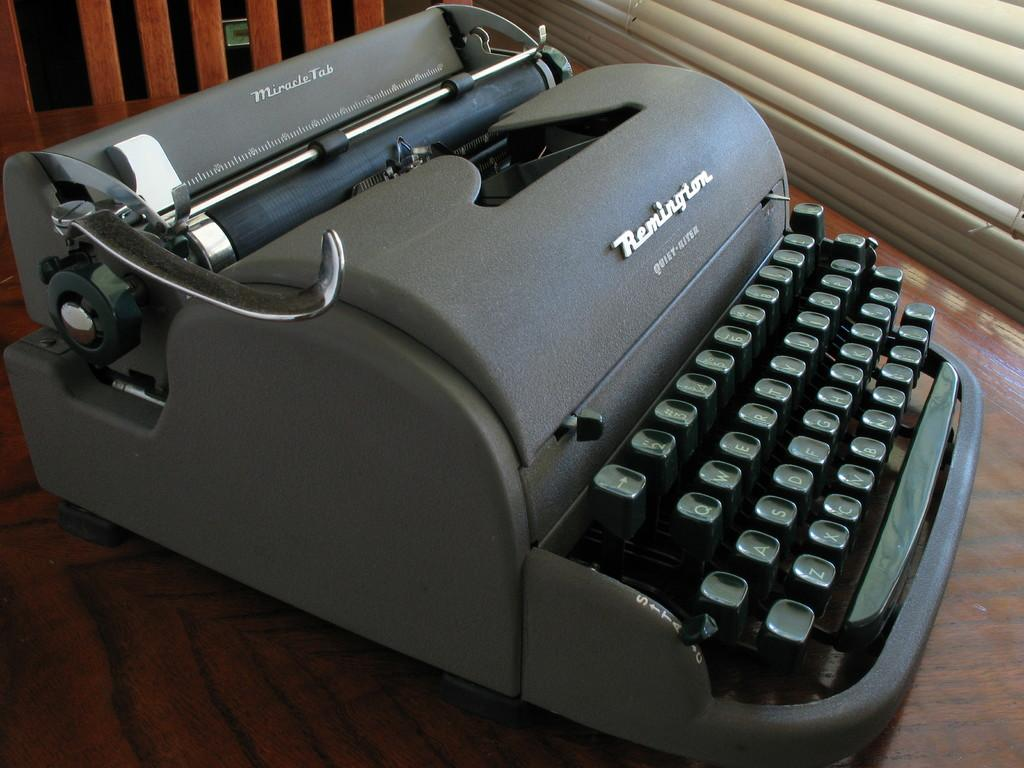<image>
Render a clear and concise summary of the photo. A black remington branded typewriter with green mechanical keys. 